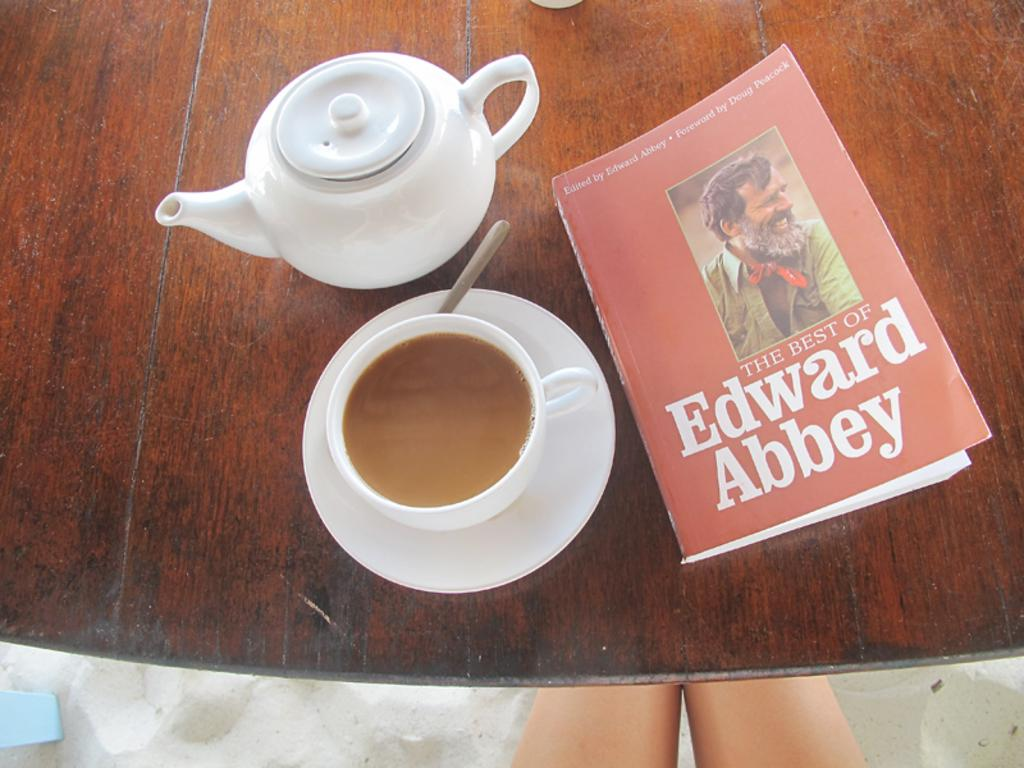<image>
Describe the image concisely. a book that has a picture on it and is titled 'the best of edward abbey' 